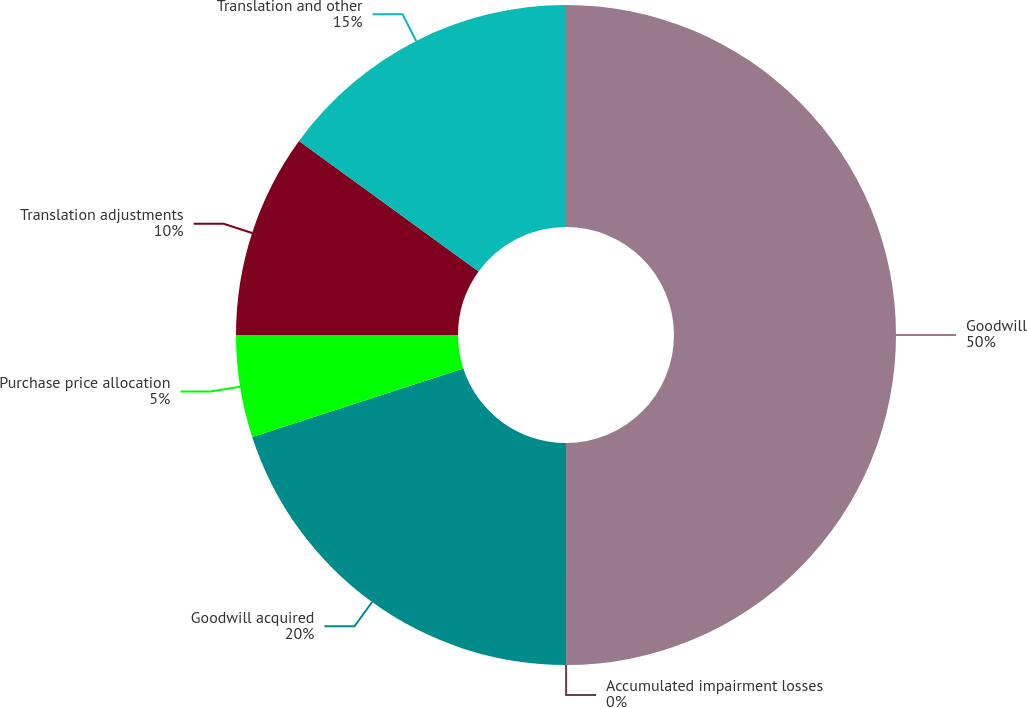<chart> <loc_0><loc_0><loc_500><loc_500><pie_chart><fcel>Goodwill<fcel>Accumulated impairment losses<fcel>Goodwill acquired<fcel>Purchase price allocation<fcel>Translation adjustments<fcel>Translation and other<nl><fcel>49.99%<fcel>0.0%<fcel>20.0%<fcel>5.0%<fcel>10.0%<fcel>15.0%<nl></chart> 